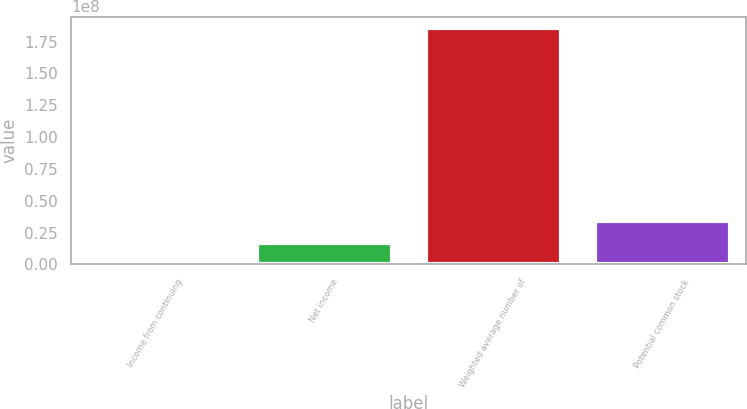Convert chart. <chart><loc_0><loc_0><loc_500><loc_500><bar_chart><fcel>Income from continuing<fcel>Net income<fcel>Weighted average number of<fcel>Potential common stock<nl><fcel>451.5<fcel>1.71176e+07<fcel>1.85365e+08<fcel>3.42347e+07<nl></chart> 